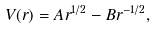<formula> <loc_0><loc_0><loc_500><loc_500>V ( r ) = A r ^ { 1 / 2 } - B r ^ { - 1 / 2 } ,</formula> 